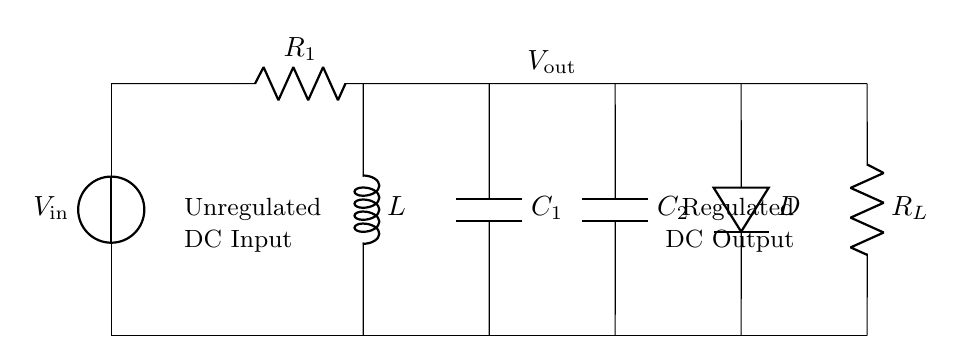What components are present in the circuit? The circuit includes a voltage source, two resistors, an inductor, and two capacitors. These components are essential for the regulator function.
Answer: Voltage source, two resistors, inductor, two capacitors What is the output voltage indicated in the circuit? The output voltage is labeled as V out, which is the voltage after regulation. The diagram does not specify a numeric value.
Answer: V out How many capacitors are used in the circuit? The circuit contains two capacitors, labeled as C1 and C2, as indicated in their respective positions.
Answer: Two What is the purpose of the inductor in this circuit? The inductor's role is to smooth out the current flow and reduce voltage fluctuations, contributing to the stability of the output.
Answer: Smooth current flow Which component regulates the output voltage? The component responsible for regulating the output voltage is the diode, which controls the direction of current flow and ensures stable output.
Answer: Diode If R1 is removed, what effect would that have? Removing R1 could disrupt the current flow and affect the overall resistance in the circuit, likely causing instability in the output voltage.
Answer: Instability in output What does R_L represent in the circuit? R_L represents the load resistor in this circuit, which is crucial for defining the load on the voltage regulator and how it interacts with the overall circuit.
Answer: Load resistor 